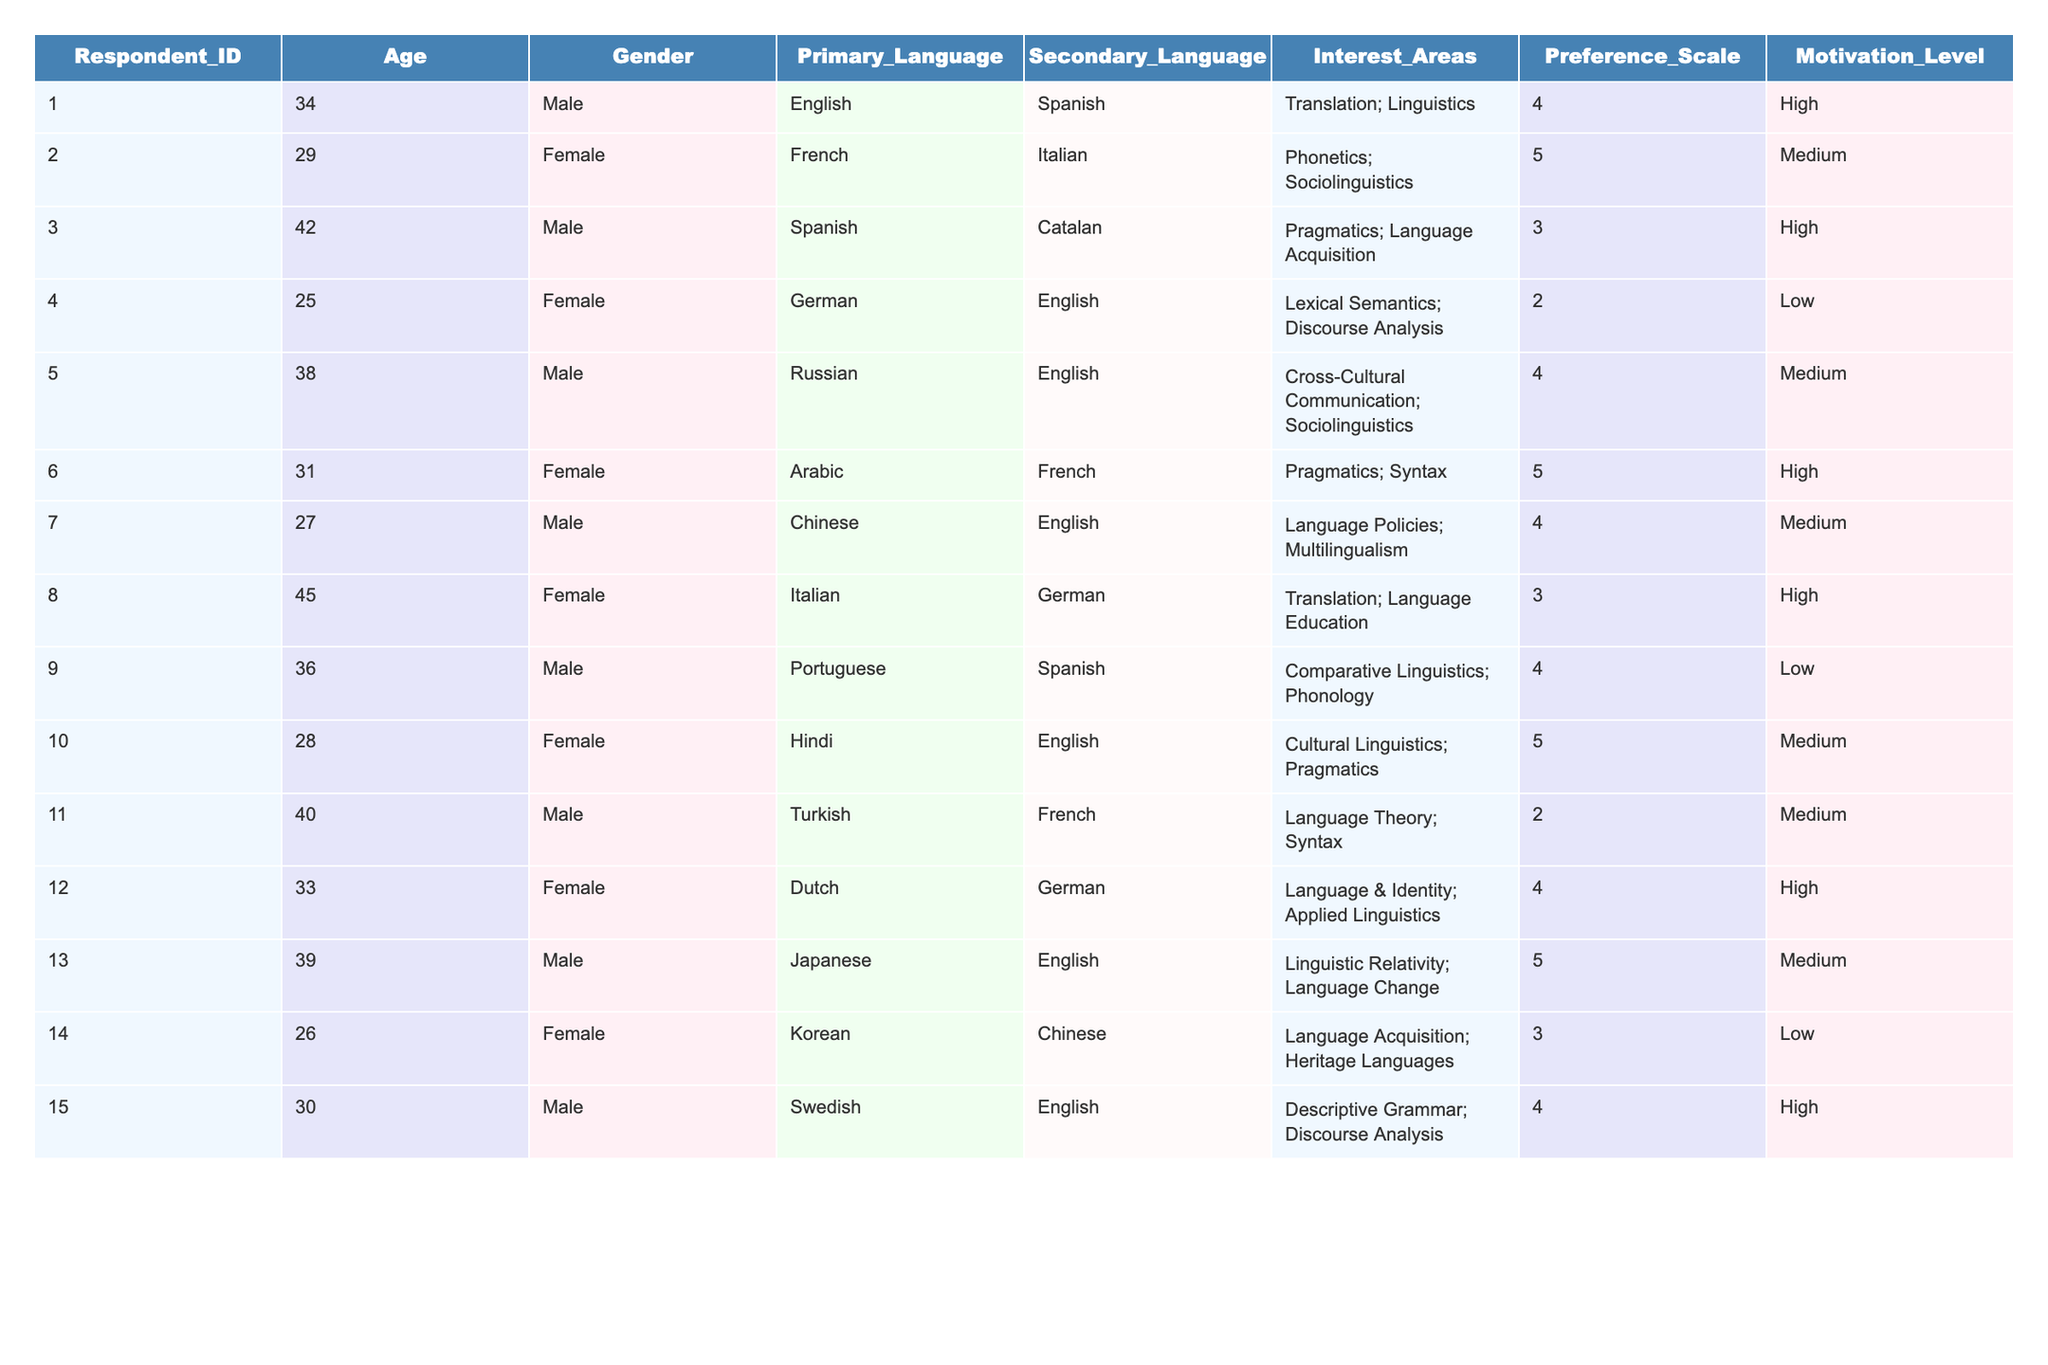What is the primary language of the oldest respondent? The oldest respondent in the table is Respondent_ID 8, who is 45 years old. Their primary language is Italian.
Answer: Italian How many respondents prefer their secondary language over their primary language? Looking through the Preference Scale for both primary and secondary languages, we see that Respondent_ID 4 and Respondent_ID 3 have lower scores for their primary languages. However, others do not clearly indicate a preference for secondary over primary, thus no definitive count.
Answer: 0 What is the average age of female respondents? The female respondents are ID 2 (29), ID 4 (25), ID 6 (31), ID 8 (45), ID 10 (28), and ID 12 (33). Their ages are summed (29 + 25 + 31 + 45 + 28 + 33 = 191), and there are 6 respondents, so the average age is 191 divided by 6 which is approximately 31.83.
Answer: 31.83 Is there a respondent who speaks Arabic as their primary language and has a high motivation level? Referring to the table, Respondent_ID 6 speaks Arabic as their primary language and has a high motivation level.
Answer: Yes What is the motivation level of respondents who have a preference scale of 4? There are four respondents with a preference scale of 4: Respondent_ID 1 (High), Respondent_ID 5 (Medium), Respondent_ID 7 (Medium), Respondent_ID 12 (High). The motivation levels are: High, Medium, Medium, and High.
Answer: High, Medium, Medium, High How many respondents have a secondary language preference of English? Looking through the Secondary Language column, respondents 5, 10, and 15 list English. Thus, there are three respondents with English as their secondary language preference.
Answer: 3 Which area of interest is most common among respondents? Reviewing the Interest Areas, "Pragmatics" appears for respondents 3, 6, and 10, making it the most common area of interest.
Answer: Pragmatics Which gender has the higher overall motivation level based on the table? By summarizing the motivation levels, we find that male respondents have 5 high and 3 medium levels while female respondents have 4 high and 2 medium levels, indicating males have a slight edge in overall motivation levels.
Answer: Male How does the age of respondents correlate with their preference scale? The age and preference scale can be analyzed individually. For example, younger respondents tend to have higher preference scales like IDs 2, 6, and 10. Gathering statistics on each preference scale would provide a clearer correlation, though no direct analysis in a single glance is evident.
Answer: Higher ages generally associate with lower preference scales What percentage of respondents listed "Language Acquisition" as an interest area? Reviewing the interest areas, "Language Acquisition" appears twice among the 15 total respondents (IDs 3 and 14), so the percentage is (2/15)*100 which is approximately 13.33%.
Answer: 13.33% 